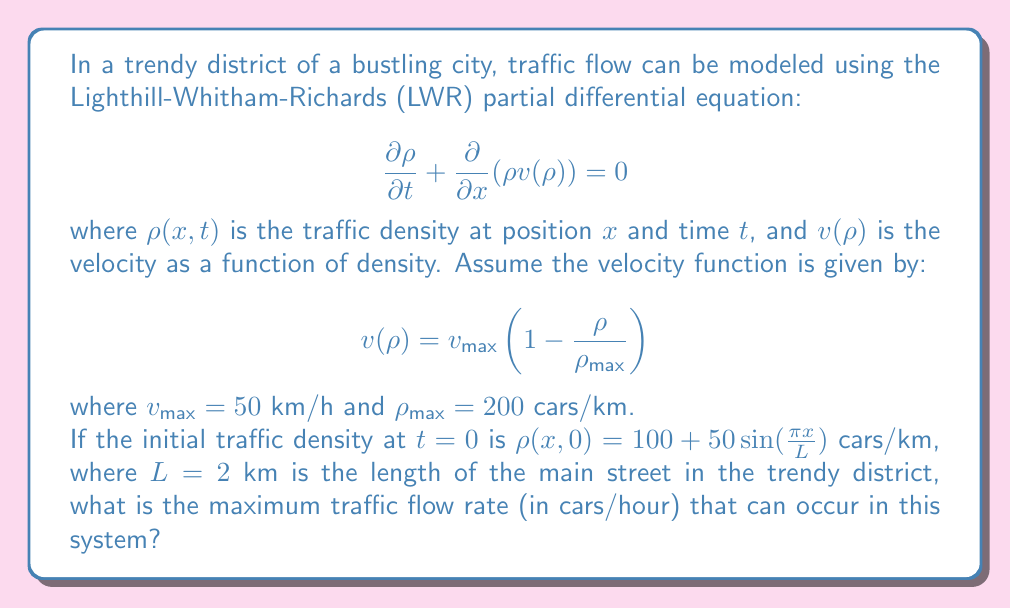Show me your answer to this math problem. To solve this problem, we need to follow these steps:

1) The traffic flow rate $q$ is given by the product of density and velocity:

   $$q = \rho v(\rho)$$

2) We need to find the maximum of this function. To do so, we can differentiate $q$ with respect to $\rho$ and set it to zero:

   $$\frac{dq}{d\rho} = v(\rho) + \rho \frac{dv}{d\rho} = 0$$

3) Using the given velocity function:

   $$v(\rho) = v_{\text{max}}\left(1 - \frac{\rho}{\rho_{\text{max}}}\right)$$

4) We can calculate $\frac{dv}{d\rho}$:

   $$\frac{dv}{d\rho} = -\frac{v_{\text{max}}}{\rho_{\text{max}}}$$

5) Substituting into the equation from step 2:

   $$v_{\text{max}}\left(1 - \frac{\rho}{\rho_{\text{max}}}\right) + \rho \left(-\frac{v_{\text{max}}}{\rho_{\text{max}}}\right) = 0$$

6) Simplifying:

   $$v_{\text{max}} - \frac{v_{\text{max}}\rho}{\rho_{\text{max}}} - \frac{v_{\text{max}}\rho}{\rho_{\text{max}}} = 0$$
   
   $$v_{\text{max}} = \frac{2v_{\text{max}}\rho}{\rho_{\text{max}}}$$

7) Solving for $\rho$:

   $$\rho = \frac{\rho_{\text{max}}}{2}$$

8) This is the density at which the maximum flow rate occurs. To find the maximum flow rate, we substitute this density back into the flow rate equation:

   $$q_{\text{max}} = \frac{\rho_{\text{max}}}{2} \cdot v_{\text{max}}\left(1 - \frac{\rho_{\text{max}}/2}{\rho_{\text{max}}}\right)$$

   $$= \frac{\rho_{\text{max}}}{2} \cdot v_{\text{max}}\left(\frac{1}{2}\right)$$

   $$= \frac{\rho_{\text{max}} \cdot v_{\text{max}}}{4}$$

9) Substituting the given values:

   $$q_{\text{max}} = \frac{200 \text{ cars/km} \cdot 50 \text{ km/h}}{4} = 2500 \text{ cars/h}$$

Note that the initial condition given in the problem doesn't affect the maximum possible flow rate, which is determined by the fundamental properties of the road (maximum density and maximum velocity).
Answer: The maximum traffic flow rate is 2500 cars/hour. 